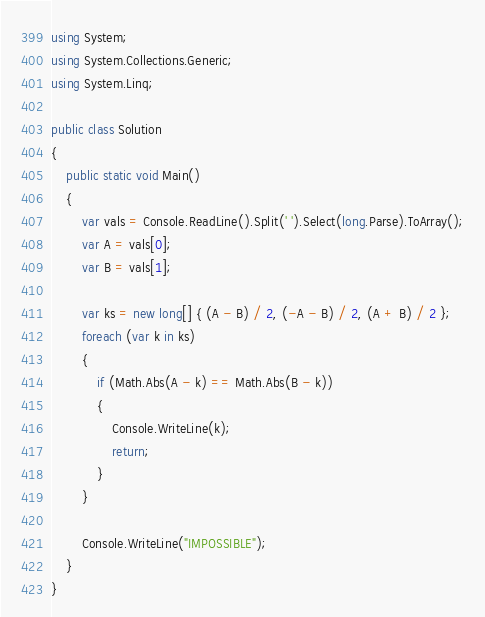<code> <loc_0><loc_0><loc_500><loc_500><_C#_>using System;
using System.Collections.Generic;
using System.Linq;

public class Solution
{
    public static void Main()
    {
        var vals = Console.ReadLine().Split(' ').Select(long.Parse).ToArray();
        var A = vals[0];
        var B = vals[1];

        var ks = new long[] { (A - B) / 2, (-A - B) / 2, (A + B) / 2 };
        foreach (var k in ks)
        {
            if (Math.Abs(A - k) == Math.Abs(B - k))
            {
                Console.WriteLine(k);
                return;
            }
        }

        Console.WriteLine("IMPOSSIBLE");
    }
}</code> 